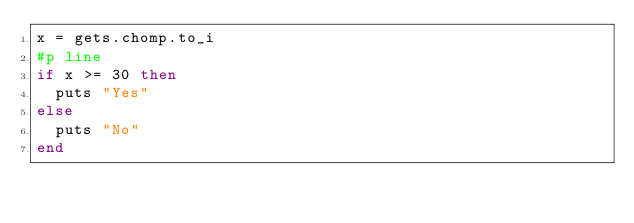<code> <loc_0><loc_0><loc_500><loc_500><_Ruby_>x = gets.chomp.to_i
#p line
if x >= 30 then
	puts "Yes"
else
	puts "No"
end

</code> 